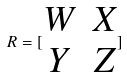Convert formula to latex. <formula><loc_0><loc_0><loc_500><loc_500>R = [ \begin{matrix} W & X \\ Y & Z \end{matrix} ]</formula> 